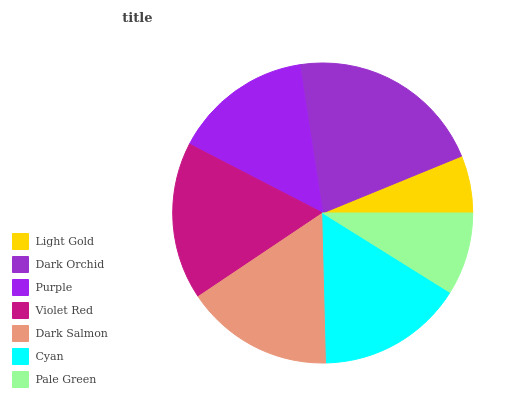Is Light Gold the minimum?
Answer yes or no. Yes. Is Dark Orchid the maximum?
Answer yes or no. Yes. Is Purple the minimum?
Answer yes or no. No. Is Purple the maximum?
Answer yes or no. No. Is Dark Orchid greater than Purple?
Answer yes or no. Yes. Is Purple less than Dark Orchid?
Answer yes or no. Yes. Is Purple greater than Dark Orchid?
Answer yes or no. No. Is Dark Orchid less than Purple?
Answer yes or no. No. Is Cyan the high median?
Answer yes or no. Yes. Is Cyan the low median?
Answer yes or no. Yes. Is Dark Orchid the high median?
Answer yes or no. No. Is Pale Green the low median?
Answer yes or no. No. 